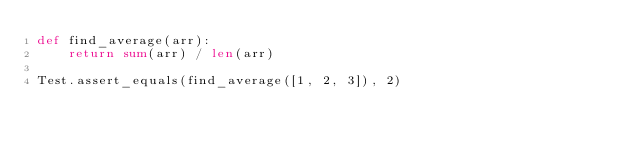<code> <loc_0><loc_0><loc_500><loc_500><_Python_>def find_average(arr):
    return sum(arr) / len(arr)

Test.assert_equals(find_average([1, 2, 3]), 2)</code> 